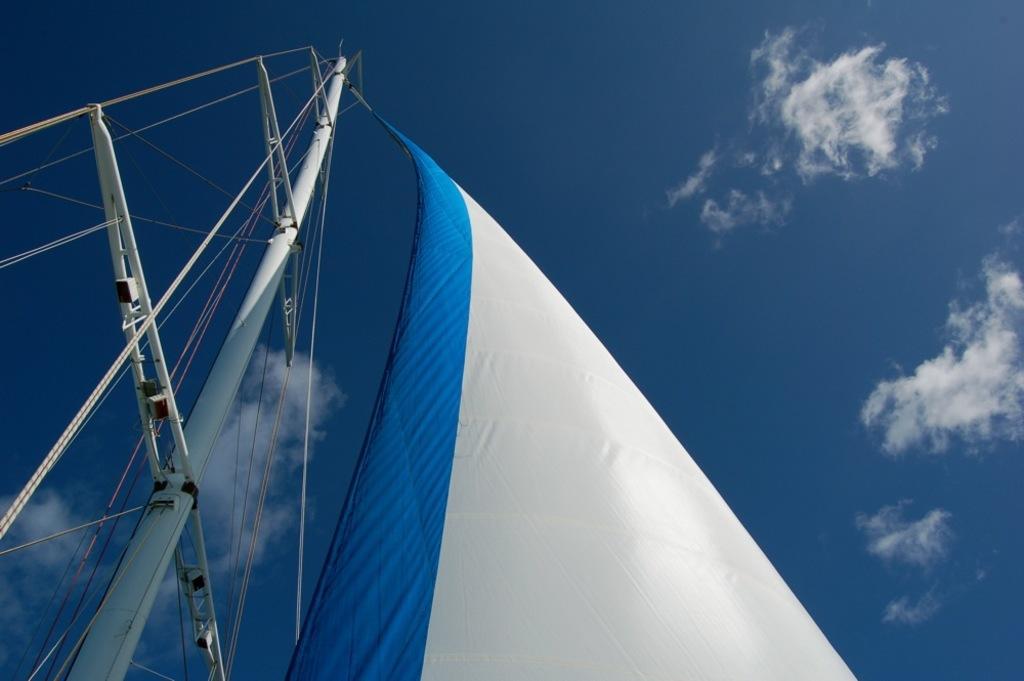How would you summarize this image in a sentence or two? In this image we can see sail of a ship which has rod and the sail is in blue and white color and top of the image there is clear sky. 